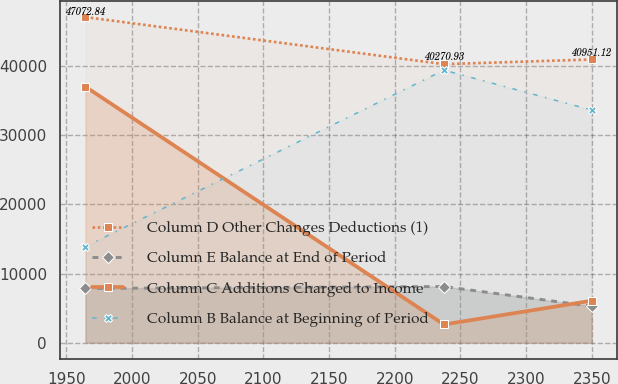<chart> <loc_0><loc_0><loc_500><loc_500><line_chart><ecel><fcel>Column D Other Changes Deductions (1)<fcel>Column E Balance at End of Period<fcel>Column C Additions Charged to Income<fcel>Column B Balance at Beginning of Period<nl><fcel>1964.61<fcel>47072.8<fcel>7850.17<fcel>37009.8<fcel>13901.9<nl><fcel>2237.48<fcel>40270.9<fcel>8127.5<fcel>2639.4<fcel>39407.9<nl><fcel>2349.97<fcel>40951.1<fcel>5275.44<fcel>6076.44<fcel>33640.5<nl></chart> 